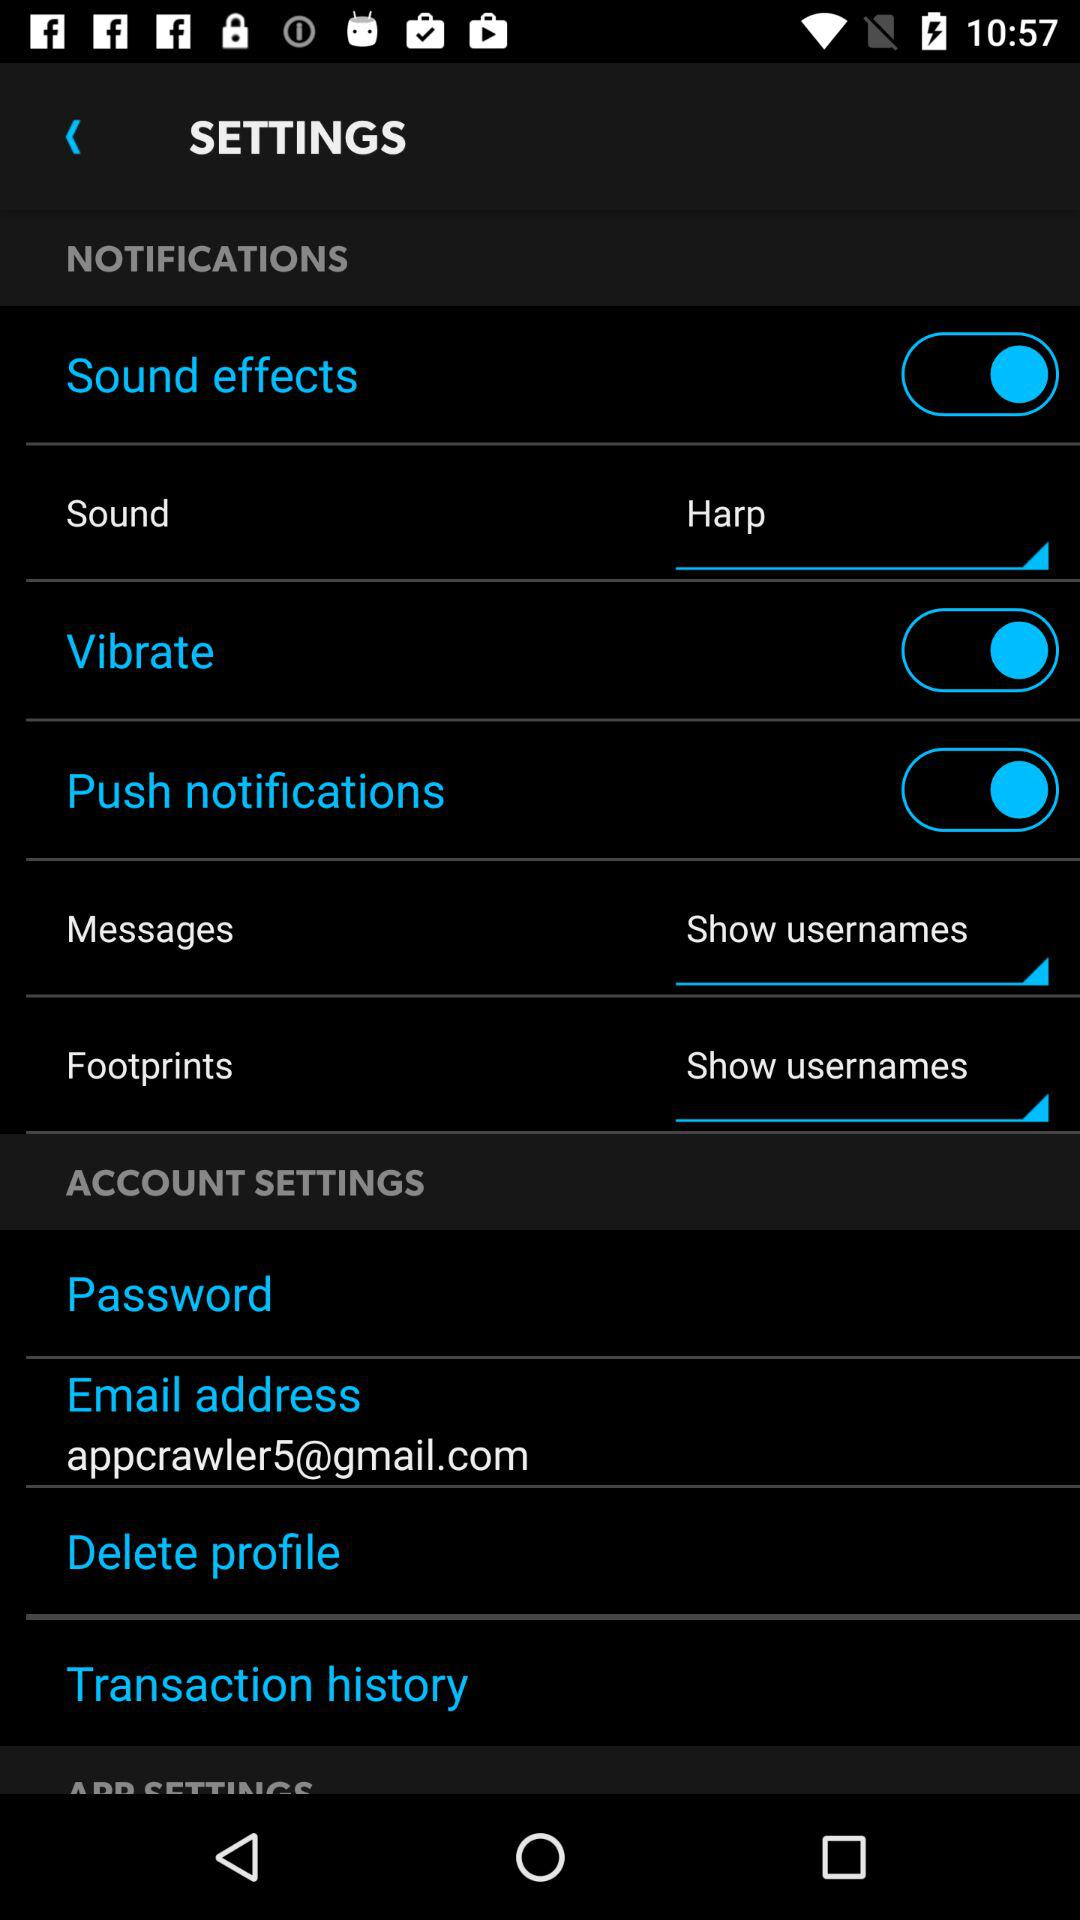What option is selected for the "Messages" setting? The selected option is "Show usernames". 